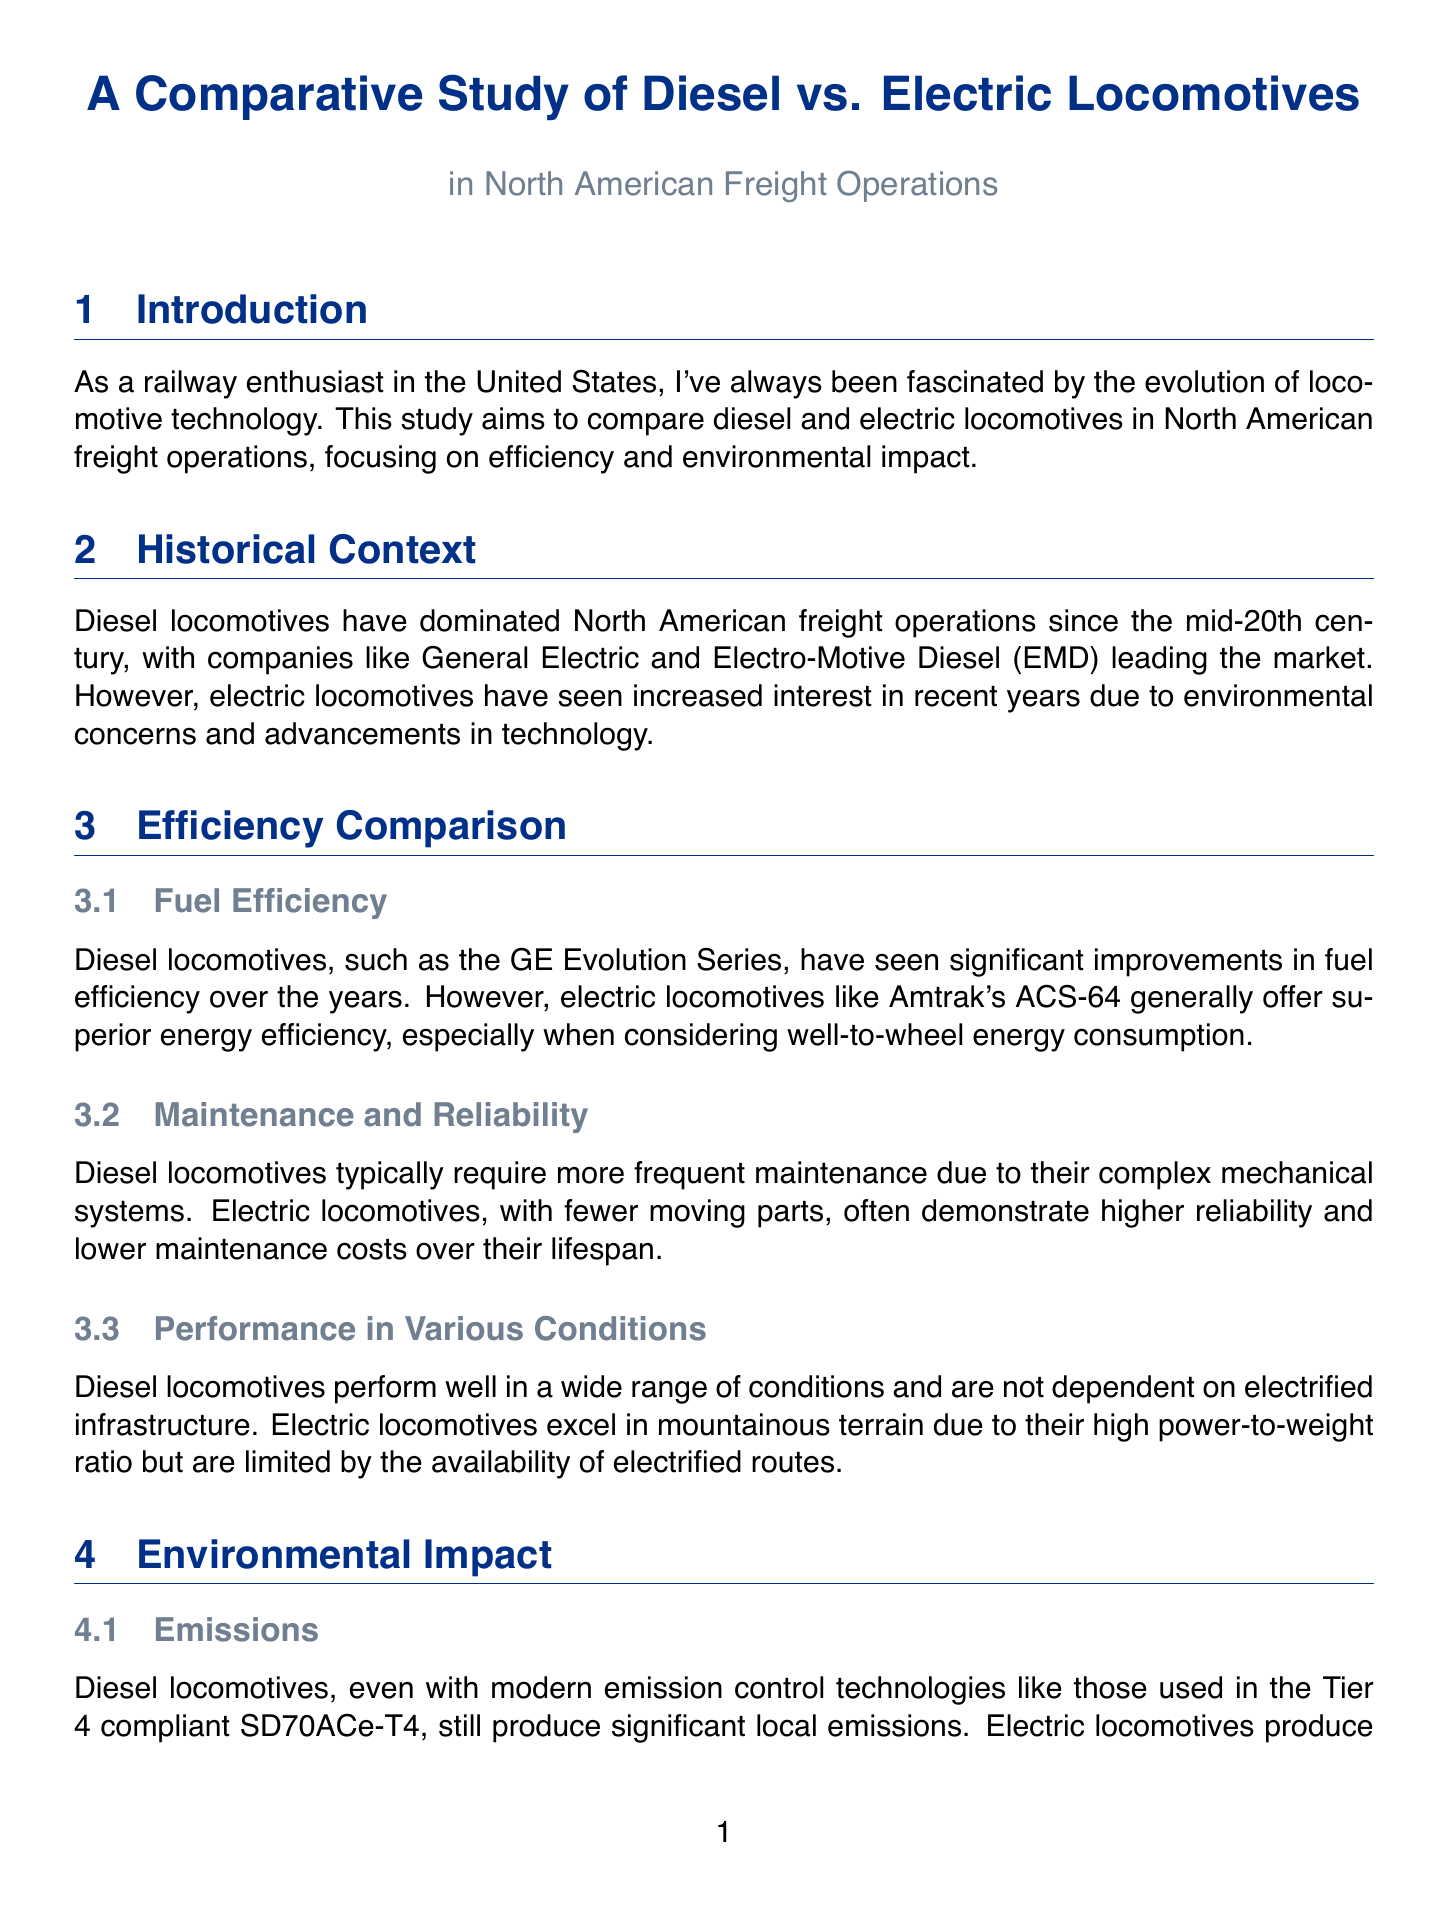what is the title of the report? The title of the report is explicitly mentioned in the document as "A Comparative Study of Diesel vs. Electric Locomotives in North American Freight Operations."
Answer: A Comparative Study of Diesel vs. Electric Locomotives in North American Freight Operations who are the leading companies in the diesel locomotive market? The document names General Electric and Electro-Motive Diesel (EMD) as leading companies in the diesel locomotive market.
Answer: General Electric and Electro-Motive Diesel which locomotive series has seen improvements in fuel efficiency? The GE Evolution Series is highlighted in the document for significant improvements in fuel efficiency.
Answer: GE Evolution Series what are the two main types of locomotives compared in the study? The study explicitly compares diesel locomotives and electric locomotives.
Answer: diesel and electric locomotives which organization is exploring hydrogen fuel cell technology? Canadian National Railway is mentioned as exploring hydrogen fuel cell technology.
Answer: Canadian National Railway what is the environmental impact of electric locomotives regarding emissions? The document states that electric locomotives produce zero local emissions.
Answer: zero local emissions what are BNSF Railway's recent efforts regarding electrification? BNSF Railway is testing electric locomotives on a short section of electrified track in Southern California.
Answer: testing electric locomotives how does maintenance frequency compare between diesel and electric locomotives? Diesel locomotives typically require more frequent maintenance than electric locomotives according to the report.
Answer: more frequent maintenance what does the future outlook of North American freight operations involve? The document indicates that the future outlook involves a mix of diesel, electric, and alternative fuel locomotives.
Answer: mix of diesel, electric, and alternative fuel locomotives 